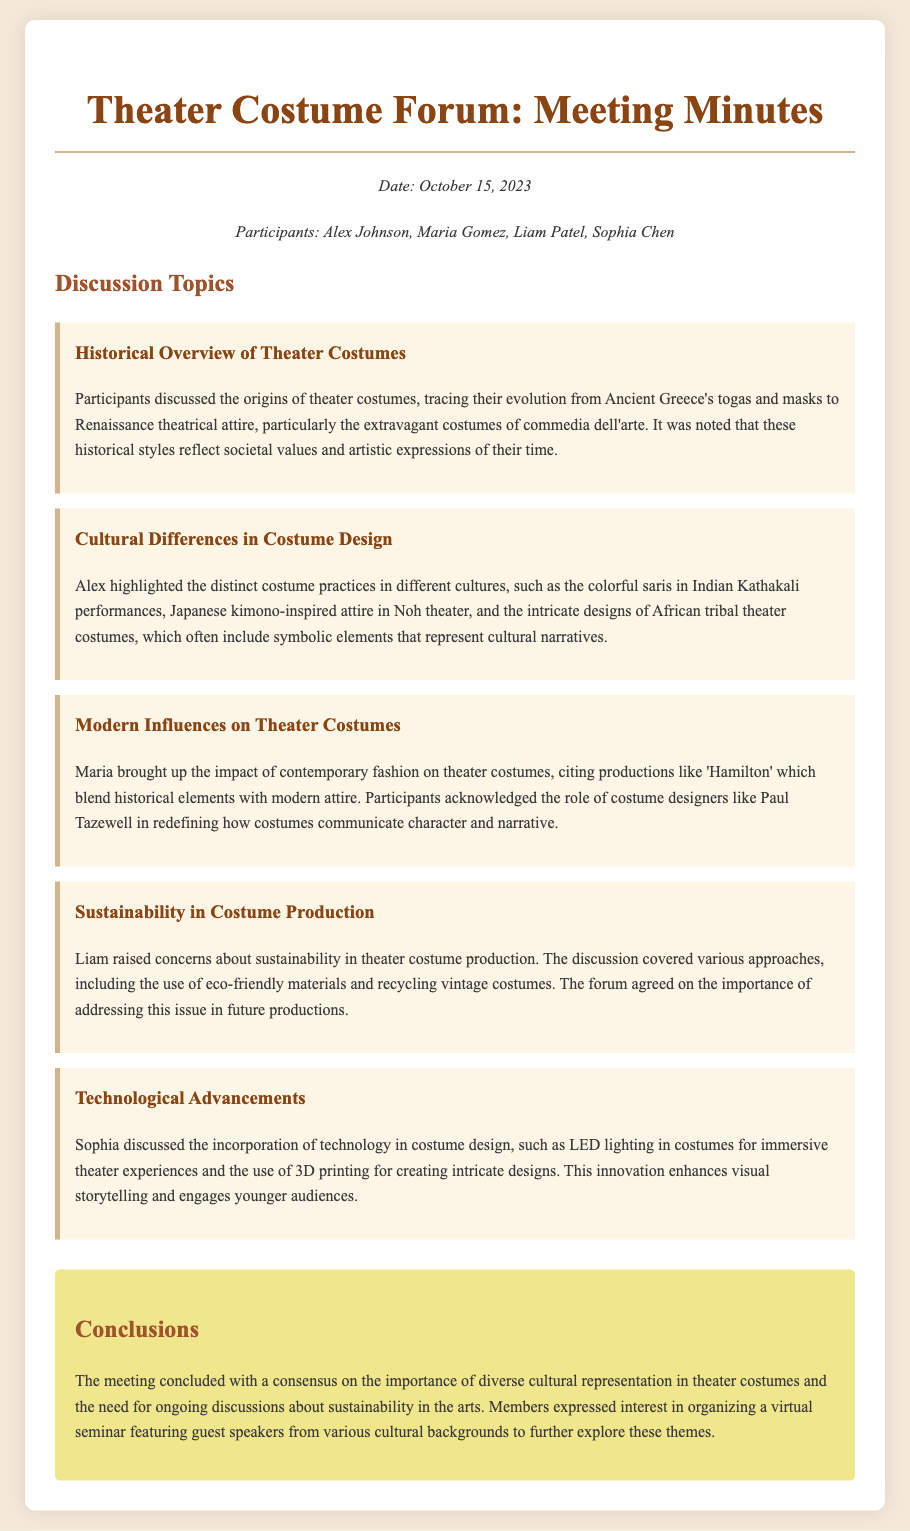What date was the meeting held? The date of the meeting is mentioned at the beginning of the document.
Answer: October 15, 2023 Who discussed the cultural differences in costume design? The participant who highlighted this topic is identified in the document.
Answer: Alex What were the concerns raised regarding costume production? The concerns discussed relate to an important aspect mentioned in the document.
Answer: Sustainability Which theatrical production was cited as blending historical and modern attire? This production is specifically referenced in the context of modern influences on theater costumes.
Answer: Hamilton What technique is being used in costumes for immersive theater experiences? The document describes innovations that enhance visual storytelling in modern theater.
Answer: LED lighting What is a proposed solution to sustainability in costume production? The document mentions an approach to address this concern.
Answer: Eco-friendly materials Which participant discussed the incorporation of technology in costume design? The participant associated with this discussion is named in the document.
Answer: Sophia What consensus was reached regarding cultural representation in theater costumes? The conclusion summarizes the collective agreement by the participants.
Answer: Importance of diverse cultural representation 